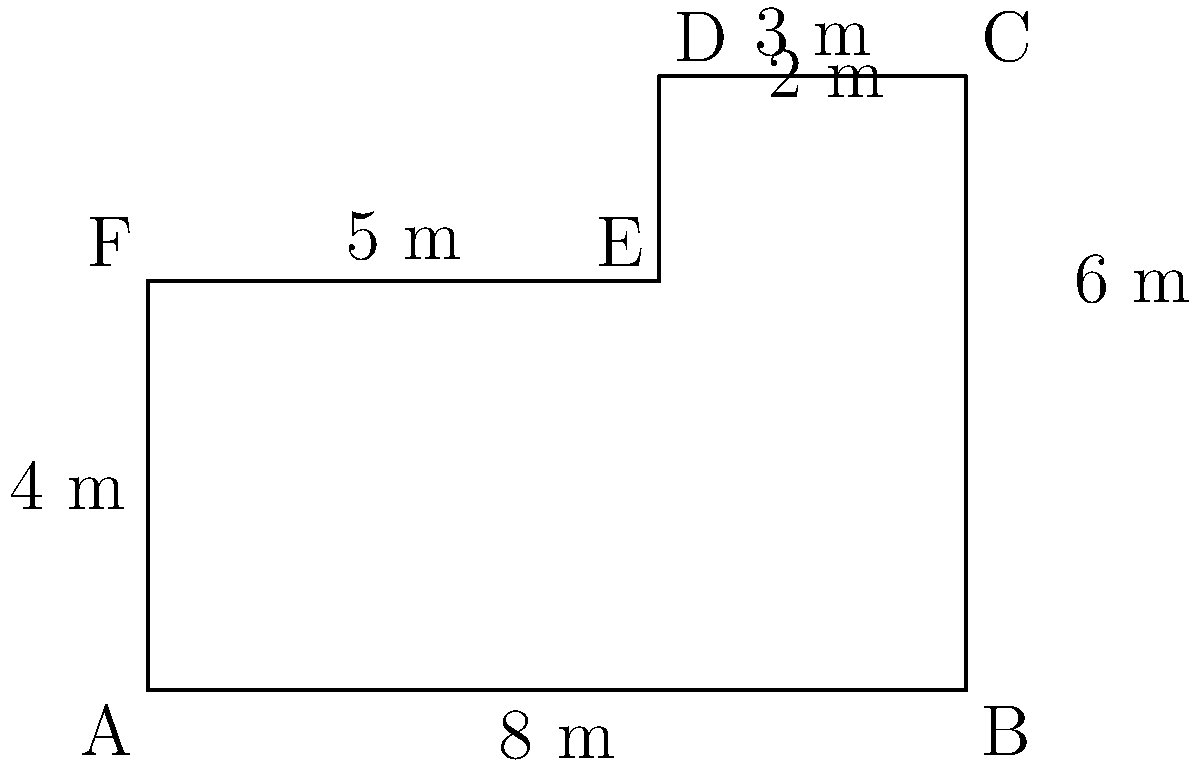As the librarian responsible for historical documents, you need to calculate the area of a new storage room for early US political dynasty records. The room has an irregular hexagonal shape, as shown in the diagram. Given the measurements provided, what is the total area of the storage room in square meters? To calculate the area of this irregular hexagon, we can divide it into simpler shapes:

1. First, let's divide the hexagon into a rectangle and a trapezoid.

2. Rectangle:
   - Width = 8 m
   - Height = 4 m
   - Area of rectangle = $8 \times 4 = 32$ m²

3. Trapezoid:
   - Base 1 = 8 m
   - Base 2 = 5 m
   - Height = 2 m
   - Area of trapezoid = $\frac{1}{2}(8 + 5) \times 2 = \frac{13}{2} \times 2 = 13$ m²

4. Total area:
   - Total area = Area of rectangle + Area of trapezoid
   - Total area = $32 + 13 = 45$ m²

Therefore, the total area of the storage room is 45 square meters.
Answer: 45 m² 